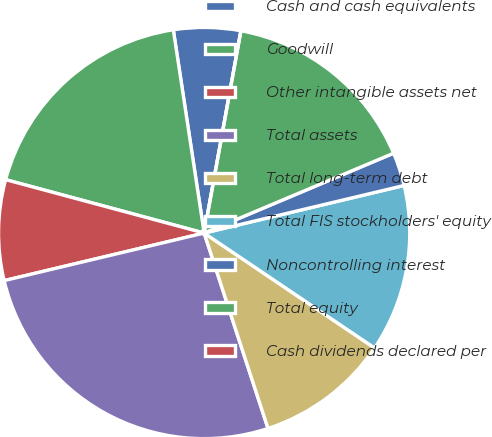<chart> <loc_0><loc_0><loc_500><loc_500><pie_chart><fcel>Cash and cash equivalents<fcel>Goodwill<fcel>Other intangible assets net<fcel>Total assets<fcel>Total long-term debt<fcel>Total FIS stockholders' equity<fcel>Noncontrolling interest<fcel>Total equity<fcel>Cash dividends declared per<nl><fcel>5.26%<fcel>18.42%<fcel>7.9%<fcel>26.31%<fcel>10.53%<fcel>13.16%<fcel>2.63%<fcel>15.79%<fcel>0.0%<nl></chart> 